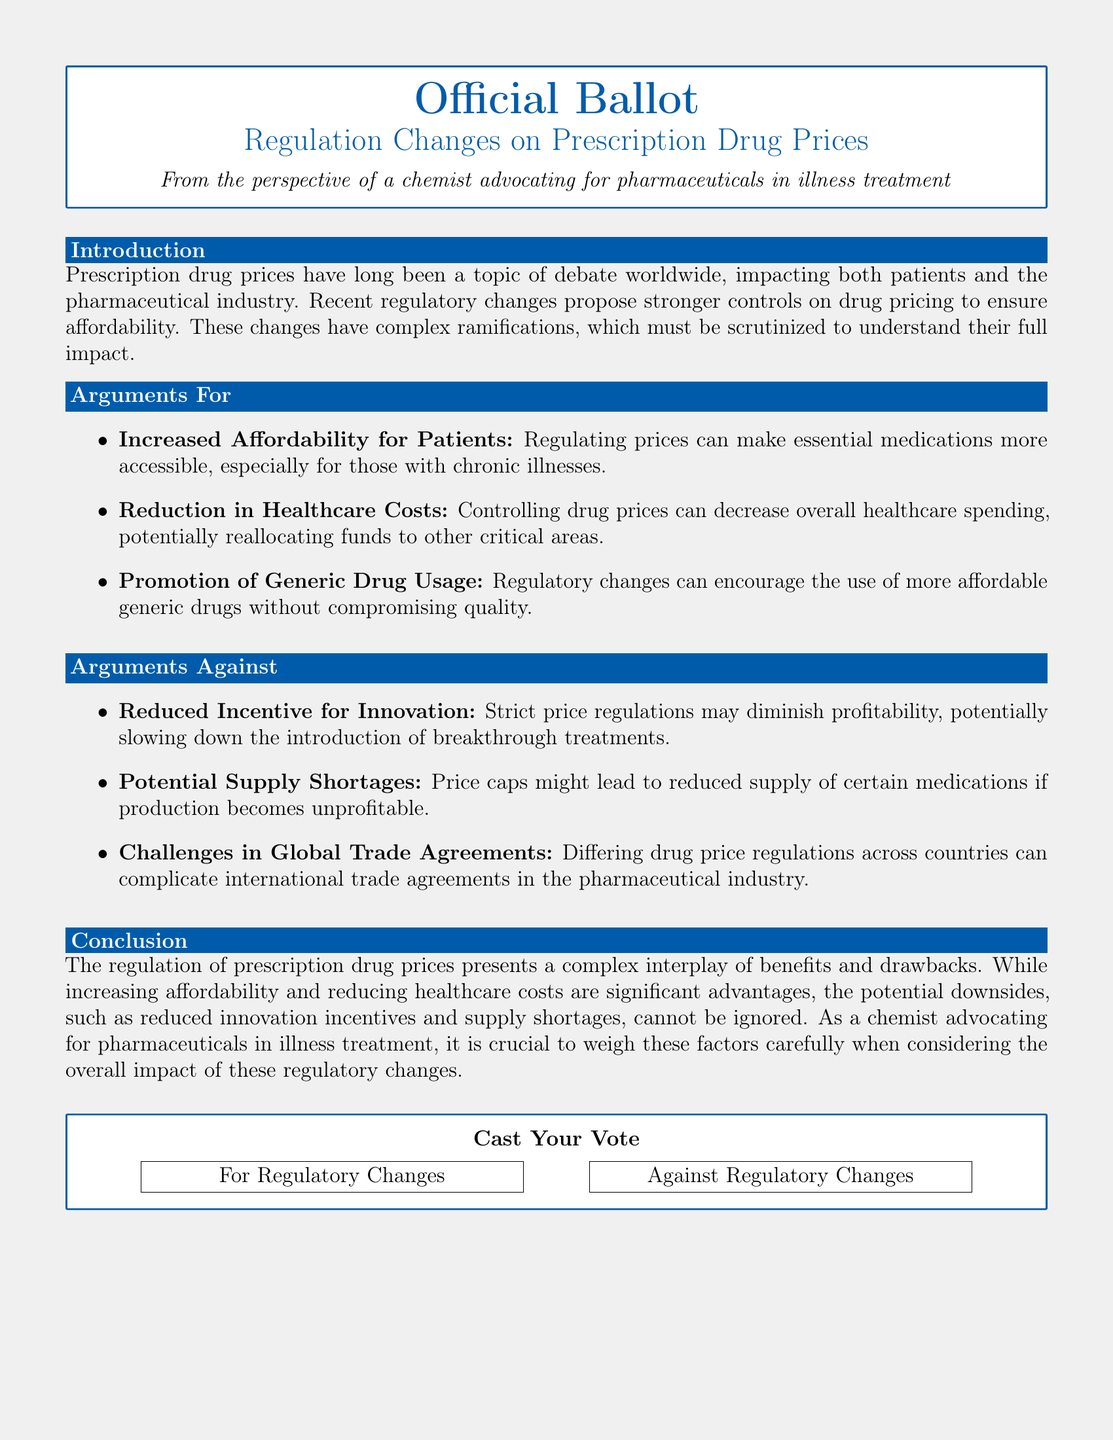What is the title of the document? The title is stated prominently at the top of the document, indicating its official nature.
Answer: Official Ballot What color is used for the ballot header? The color representing the ballot header is specified in RGB format in the document.
Answer: Ballot blue What are two arguments for regulating drug prices? The document lists arguments in favor of regulation, highlighting benefits for patients and overall healthcare costs.
Answer: Increased affordability for patients, reduction in healthcare costs What is a potential challenge mentioned regarding international trade? The document identifies complications in global trade agreements as a drawback of differing drug price regulations.
Answer: Challenges in global trade agreements What is one argument against regulatory changes? The document outlines drawbacks of regulation, affecting the pharmaceutical industry's innovation incentives.
Answer: Reduced incentive for innovation How many arguments are listed against the regulatory changes? The document clearly enumerates the arguments against, providing a specific count.
Answer: Three arguments What conclusion is drawn about the regulation of prescription drug prices? The conclusion summarizes the complexities of regulating drug prices, emphasizing the need to weigh factors carefully.
Answer: Complex interplay of benefits and drawbacks What action does the ballot prompt readers to take? The document concludes with a call to action, inviting participants to express their opinion.
Answer: Cast Your Vote 